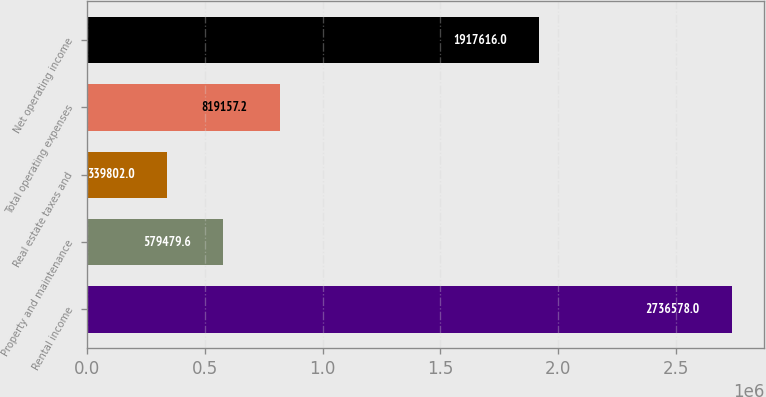<chart> <loc_0><loc_0><loc_500><loc_500><bar_chart><fcel>Rental income<fcel>Property and maintenance<fcel>Real estate taxes and<fcel>Total operating expenses<fcel>Net operating income<nl><fcel>2.73658e+06<fcel>579480<fcel>339802<fcel>819157<fcel>1.91762e+06<nl></chart> 